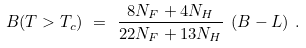Convert formula to latex. <formula><loc_0><loc_0><loc_500><loc_500>B ( T > T _ { c } ) \ = \ \frac { 8 N _ { F } + 4 N _ { H } } { 2 2 N _ { F } + 1 3 N _ { H } } \ ( B - L ) \ .</formula> 